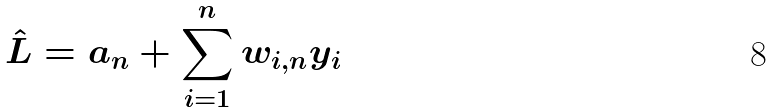Convert formula to latex. <formula><loc_0><loc_0><loc_500><loc_500>\hat { L } = a _ { n } + \sum _ { i = 1 } ^ { n } w _ { i , n } y _ { i }</formula> 